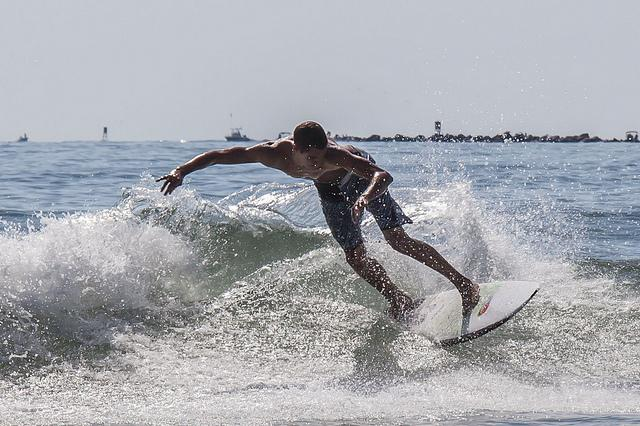Why is he leaning forward? balance 